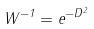<formula> <loc_0><loc_0><loc_500><loc_500>W ^ { - 1 } = e ^ { - D ^ { 2 } }</formula> 